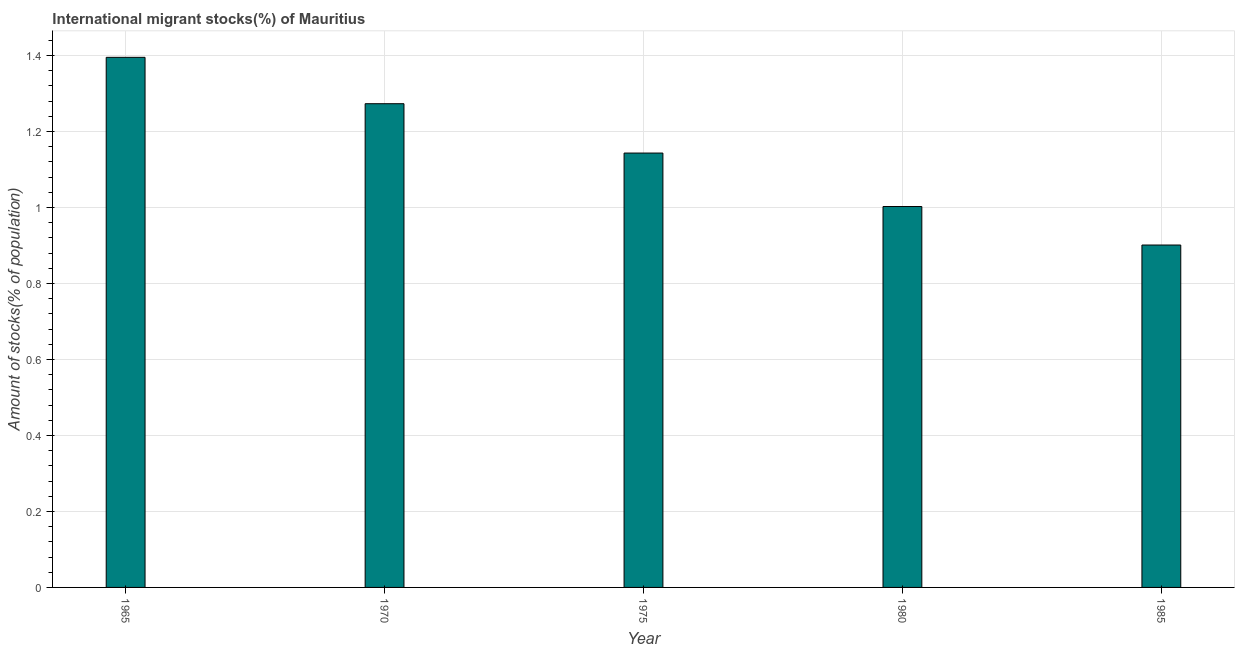Does the graph contain any zero values?
Provide a short and direct response. No. What is the title of the graph?
Keep it short and to the point. International migrant stocks(%) of Mauritius. What is the label or title of the X-axis?
Your answer should be compact. Year. What is the label or title of the Y-axis?
Provide a succinct answer. Amount of stocks(% of population). What is the number of international migrant stocks in 1975?
Your response must be concise. 1.14. Across all years, what is the maximum number of international migrant stocks?
Offer a very short reply. 1.4. Across all years, what is the minimum number of international migrant stocks?
Your response must be concise. 0.9. In which year was the number of international migrant stocks maximum?
Keep it short and to the point. 1965. In which year was the number of international migrant stocks minimum?
Make the answer very short. 1985. What is the sum of the number of international migrant stocks?
Give a very brief answer. 5.72. What is the difference between the number of international migrant stocks in 1975 and 1985?
Offer a terse response. 0.24. What is the average number of international migrant stocks per year?
Keep it short and to the point. 1.14. What is the median number of international migrant stocks?
Ensure brevity in your answer.  1.14. Do a majority of the years between 1965 and 1975 (inclusive) have number of international migrant stocks greater than 0.04 %?
Your answer should be very brief. Yes. What is the ratio of the number of international migrant stocks in 1965 to that in 1985?
Your answer should be compact. 1.55. What is the difference between the highest and the second highest number of international migrant stocks?
Ensure brevity in your answer.  0.12. What is the difference between the highest and the lowest number of international migrant stocks?
Keep it short and to the point. 0.49. In how many years, is the number of international migrant stocks greater than the average number of international migrant stocks taken over all years?
Your answer should be compact. 3. What is the difference between two consecutive major ticks on the Y-axis?
Offer a very short reply. 0.2. What is the Amount of stocks(% of population) in 1965?
Keep it short and to the point. 1.4. What is the Amount of stocks(% of population) of 1970?
Offer a very short reply. 1.27. What is the Amount of stocks(% of population) in 1975?
Offer a terse response. 1.14. What is the Amount of stocks(% of population) of 1980?
Keep it short and to the point. 1. What is the Amount of stocks(% of population) in 1985?
Your response must be concise. 0.9. What is the difference between the Amount of stocks(% of population) in 1965 and 1970?
Offer a terse response. 0.12. What is the difference between the Amount of stocks(% of population) in 1965 and 1975?
Give a very brief answer. 0.25. What is the difference between the Amount of stocks(% of population) in 1965 and 1980?
Offer a terse response. 0.39. What is the difference between the Amount of stocks(% of population) in 1965 and 1985?
Ensure brevity in your answer.  0.49. What is the difference between the Amount of stocks(% of population) in 1970 and 1975?
Make the answer very short. 0.13. What is the difference between the Amount of stocks(% of population) in 1970 and 1980?
Make the answer very short. 0.27. What is the difference between the Amount of stocks(% of population) in 1970 and 1985?
Offer a very short reply. 0.37. What is the difference between the Amount of stocks(% of population) in 1975 and 1980?
Provide a short and direct response. 0.14. What is the difference between the Amount of stocks(% of population) in 1975 and 1985?
Give a very brief answer. 0.24. What is the difference between the Amount of stocks(% of population) in 1980 and 1985?
Your answer should be compact. 0.1. What is the ratio of the Amount of stocks(% of population) in 1965 to that in 1970?
Your answer should be compact. 1.1. What is the ratio of the Amount of stocks(% of population) in 1965 to that in 1975?
Make the answer very short. 1.22. What is the ratio of the Amount of stocks(% of population) in 1965 to that in 1980?
Offer a very short reply. 1.39. What is the ratio of the Amount of stocks(% of population) in 1965 to that in 1985?
Your response must be concise. 1.55. What is the ratio of the Amount of stocks(% of population) in 1970 to that in 1975?
Keep it short and to the point. 1.11. What is the ratio of the Amount of stocks(% of population) in 1970 to that in 1980?
Your answer should be very brief. 1.27. What is the ratio of the Amount of stocks(% of population) in 1970 to that in 1985?
Make the answer very short. 1.41. What is the ratio of the Amount of stocks(% of population) in 1975 to that in 1980?
Keep it short and to the point. 1.14. What is the ratio of the Amount of stocks(% of population) in 1975 to that in 1985?
Ensure brevity in your answer.  1.27. What is the ratio of the Amount of stocks(% of population) in 1980 to that in 1985?
Give a very brief answer. 1.11. 